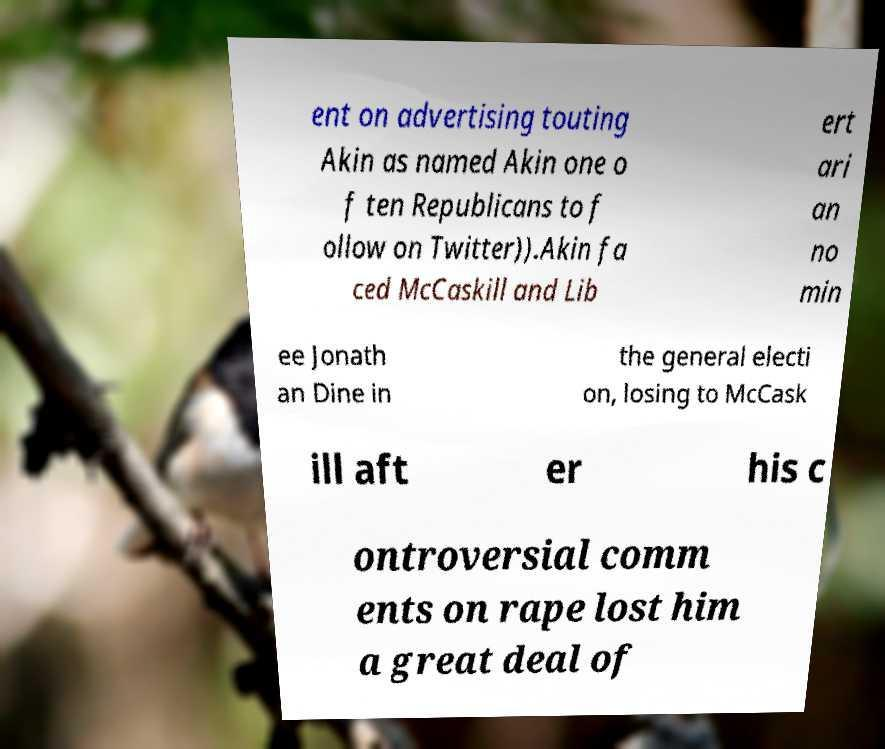Could you extract and type out the text from this image? ent on advertising touting Akin as named Akin one o f ten Republicans to f ollow on Twitter)).Akin fa ced McCaskill and Lib ert ari an no min ee Jonath an Dine in the general electi on, losing to McCask ill aft er his c ontroversial comm ents on rape lost him a great deal of 